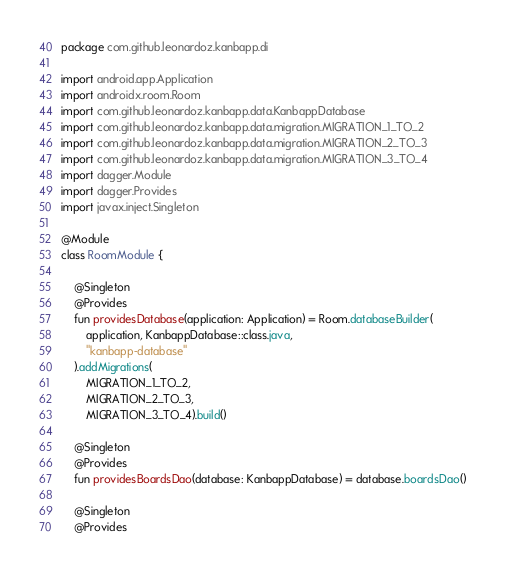<code> <loc_0><loc_0><loc_500><loc_500><_Kotlin_>package com.github.leonardoz.kanbapp.di

import android.app.Application
import androidx.room.Room
import com.github.leonardoz.kanbapp.data.KanbappDatabase
import com.github.leonardoz.kanbapp.data.migration.MIGRATION_1_TO_2
import com.github.leonardoz.kanbapp.data.migration.MIGRATION_2_TO_3
import com.github.leonardoz.kanbapp.data.migration.MIGRATION_3_TO_4
import dagger.Module
import dagger.Provides
import javax.inject.Singleton

@Module
class RoomModule {

    @Singleton
    @Provides
    fun providesDatabase(application: Application) = Room.databaseBuilder(
        application, KanbappDatabase::class.java,
        "kanbapp-database"
    ).addMigrations(
        MIGRATION_1_TO_2,
        MIGRATION_2_TO_3,
        MIGRATION_3_TO_4).build()

    @Singleton
    @Provides
    fun providesBoardsDao(database: KanbappDatabase) = database.boardsDao()

    @Singleton
    @Provides</code> 